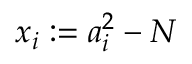Convert formula to latex. <formula><loc_0><loc_0><loc_500><loc_500>x _ { i } \colon = a _ { i } ^ { 2 } - N</formula> 